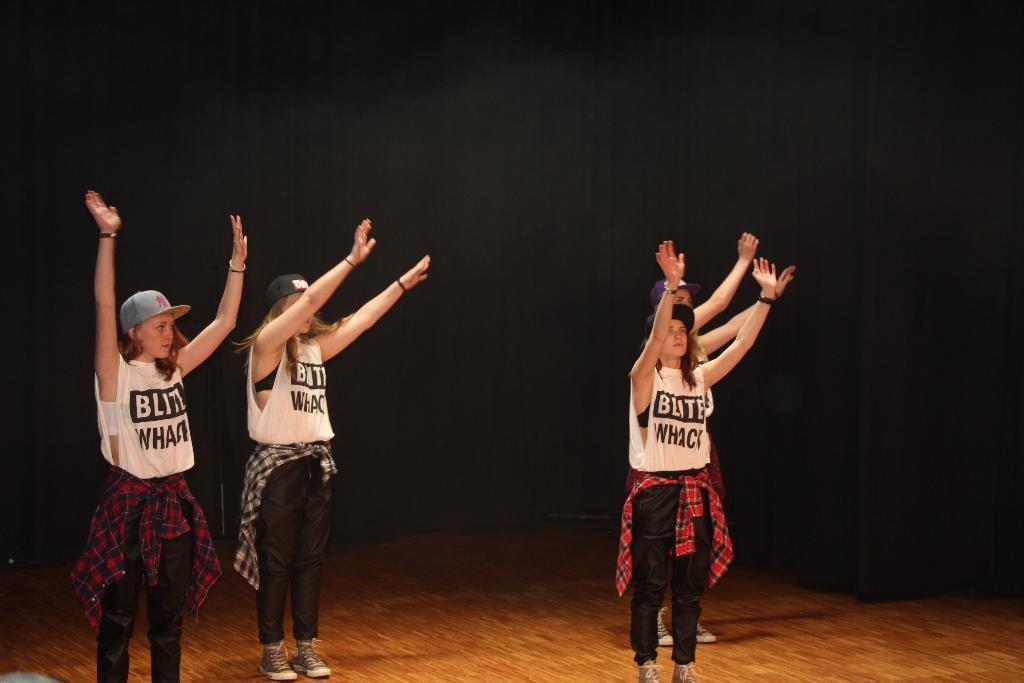In one or two sentences, can you explain what this image depicts? In this picture I can see 4 women, who are standing and I see that they're wearing same color dresses and they're on the brown color floor and it is dark in the background. 